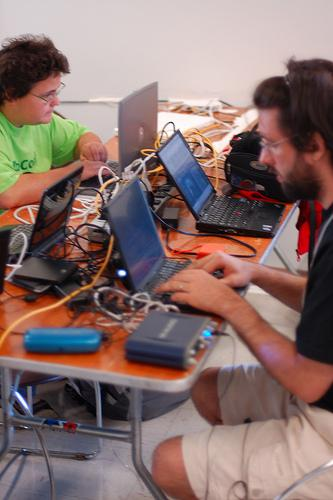What is a common interaction between people and objects in the image?  A common interaction in the image is people using laptop computers on the table. Describe the floor's appearance based on the image. The floor is white linoleum flooring, resembling a white tile floor. Find a fashion accessory worn by a man in the image and describe its color. A man is wearing glasses with a blue case in the image. Enumerate some objects that can be found underneath the table. Underneath the table, one can find metal bars, lots of tangled computer cables, and a USA label on table legs. What is a recurrent object in the image, and how many instances of this object are present in the image? A recurrent object is a man wearing shorts, and there are 7 instances of this object in the image. Mention one action a person is performing in the image and describe the person's clothing. A man on a laptop is typing while wearing a green shirt and tan shorts. Identify an object stuck on the table legs and describe its theme. A USA sticker is stuck on the table legs, representing the theme of patriotism. Enumerate the types of laptops present in the image based on their color mentioned in the image. There are two types of laptops: black laptops and silver laptops. How many surge protectors are mentioned in the image, and what do they appear to be used for? There is one surge protector mentioned, and it appears to be used for managing tangled computer cables. Provide an estimation of the number of laptops on the wooden table and mention their primary color. There are at least four laptops on the wooden table, with black and silver being their primary colors. Describe an object in this image related to power supply. power adapter for a laptop Did you notice the skateboard leaning on the wooden table with laptops on it? It's got some really cool graffiti designs. No, it's not mentioned in the image. Describe the expression of the man with long hair. Not enough information to determine the facial expression. A man with a unique accessory is present in the image. Describe the accessory. a ring on a man's finger Does the man wearing a black shirt have any noticeable facial features? Not enough information to determine specific facial features. What material are the bars under the table made of? metal In this image, what kind of flooring is present? white linoleum flooring and white tile floor List the colors of the cords on the table. yellow, black, and white What kind of shirt is the man with glasses wearing? a green shirt Identify the type of table in the image. a wooden table with metal legs Identify the main event taking place in this image. people using laptops on a table Explain what is happening in the image using simple language for a child. Some people are sitting around a table with laptops, using them and talking. Rewrite the following caption in a more poetic style: "a man wearing tan shorts." A gentleman adorned in sun-kissed breeches What activity is the person wearing a green t-shirt engaged in? using a laptop Describe the appearance of the wall in the image. bare white wall Which object is located at the top-left corner of the image? a man wearing glasses State the type of container seen in the image. a blue case for glasses Which of the following laptop colors are present in the image: black, silver, red, blue? black, silver Are there any visible logos or labels in the image? a usa sticker How many laptops can you see in the image? four What do most of the objects on the table have in common? they are all laptops or related to using laptops 